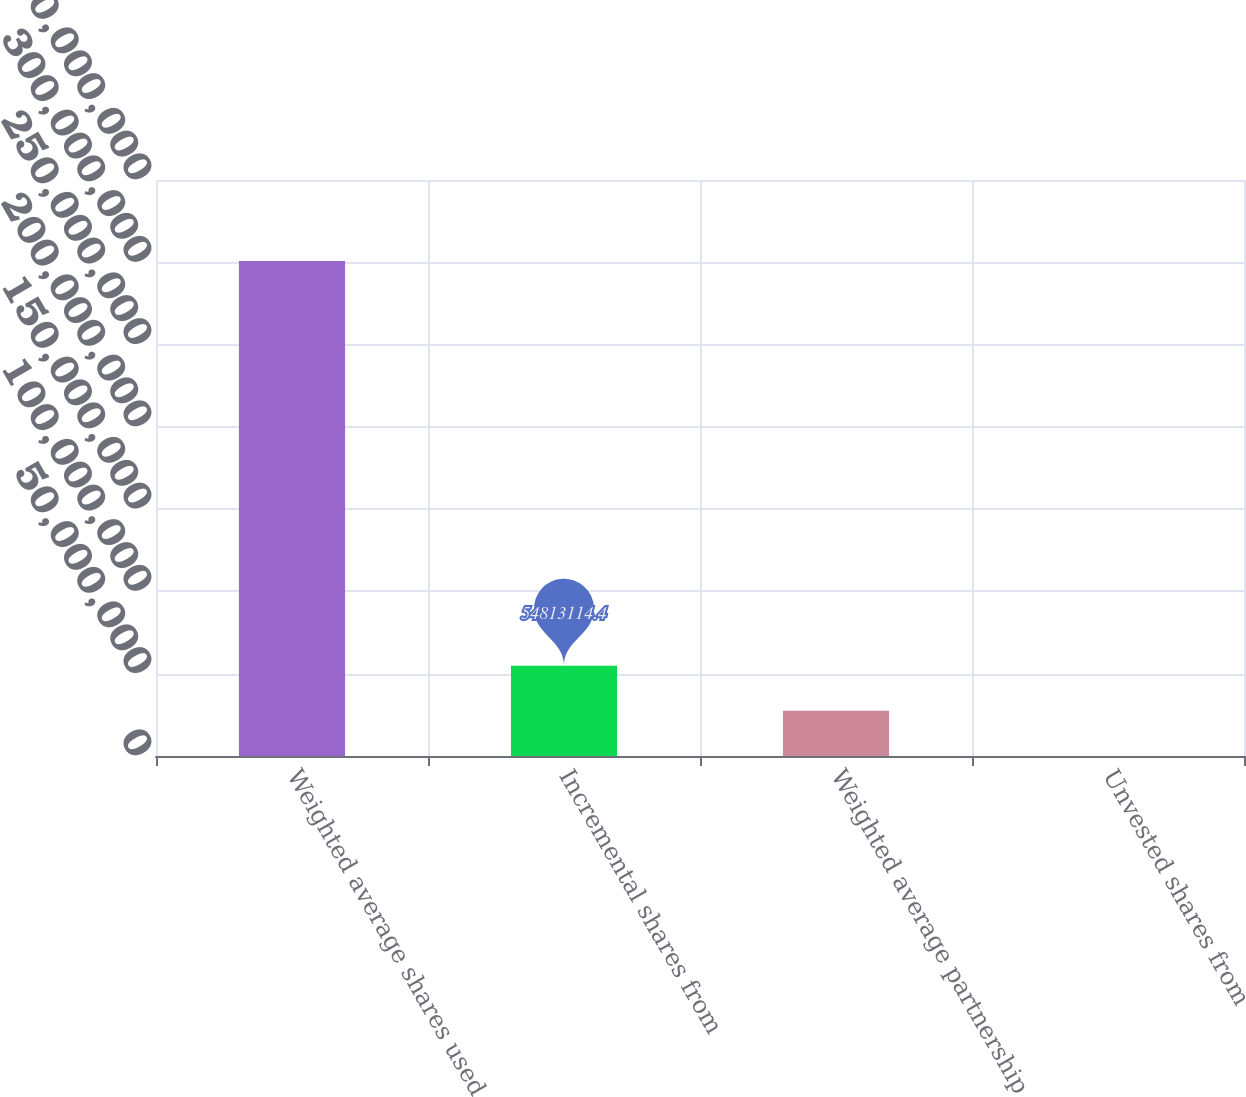<chart> <loc_0><loc_0><loc_500><loc_500><bar_chart><fcel>Weighted average shares used<fcel>Incremental shares from<fcel>Weighted average partnership<fcel>Unvested shares from<nl><fcel>3.00856e+08<fcel>5.48131e+07<fcel>2.74227e+07<fcel>32205<nl></chart> 